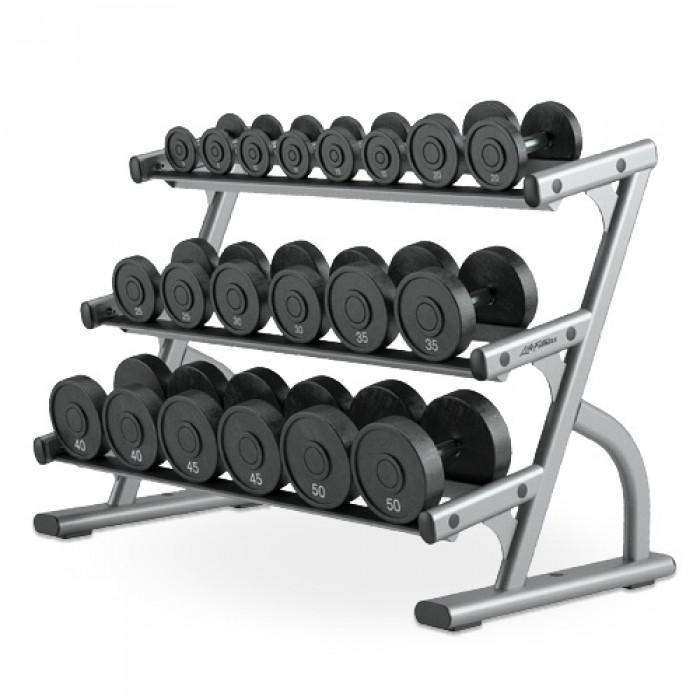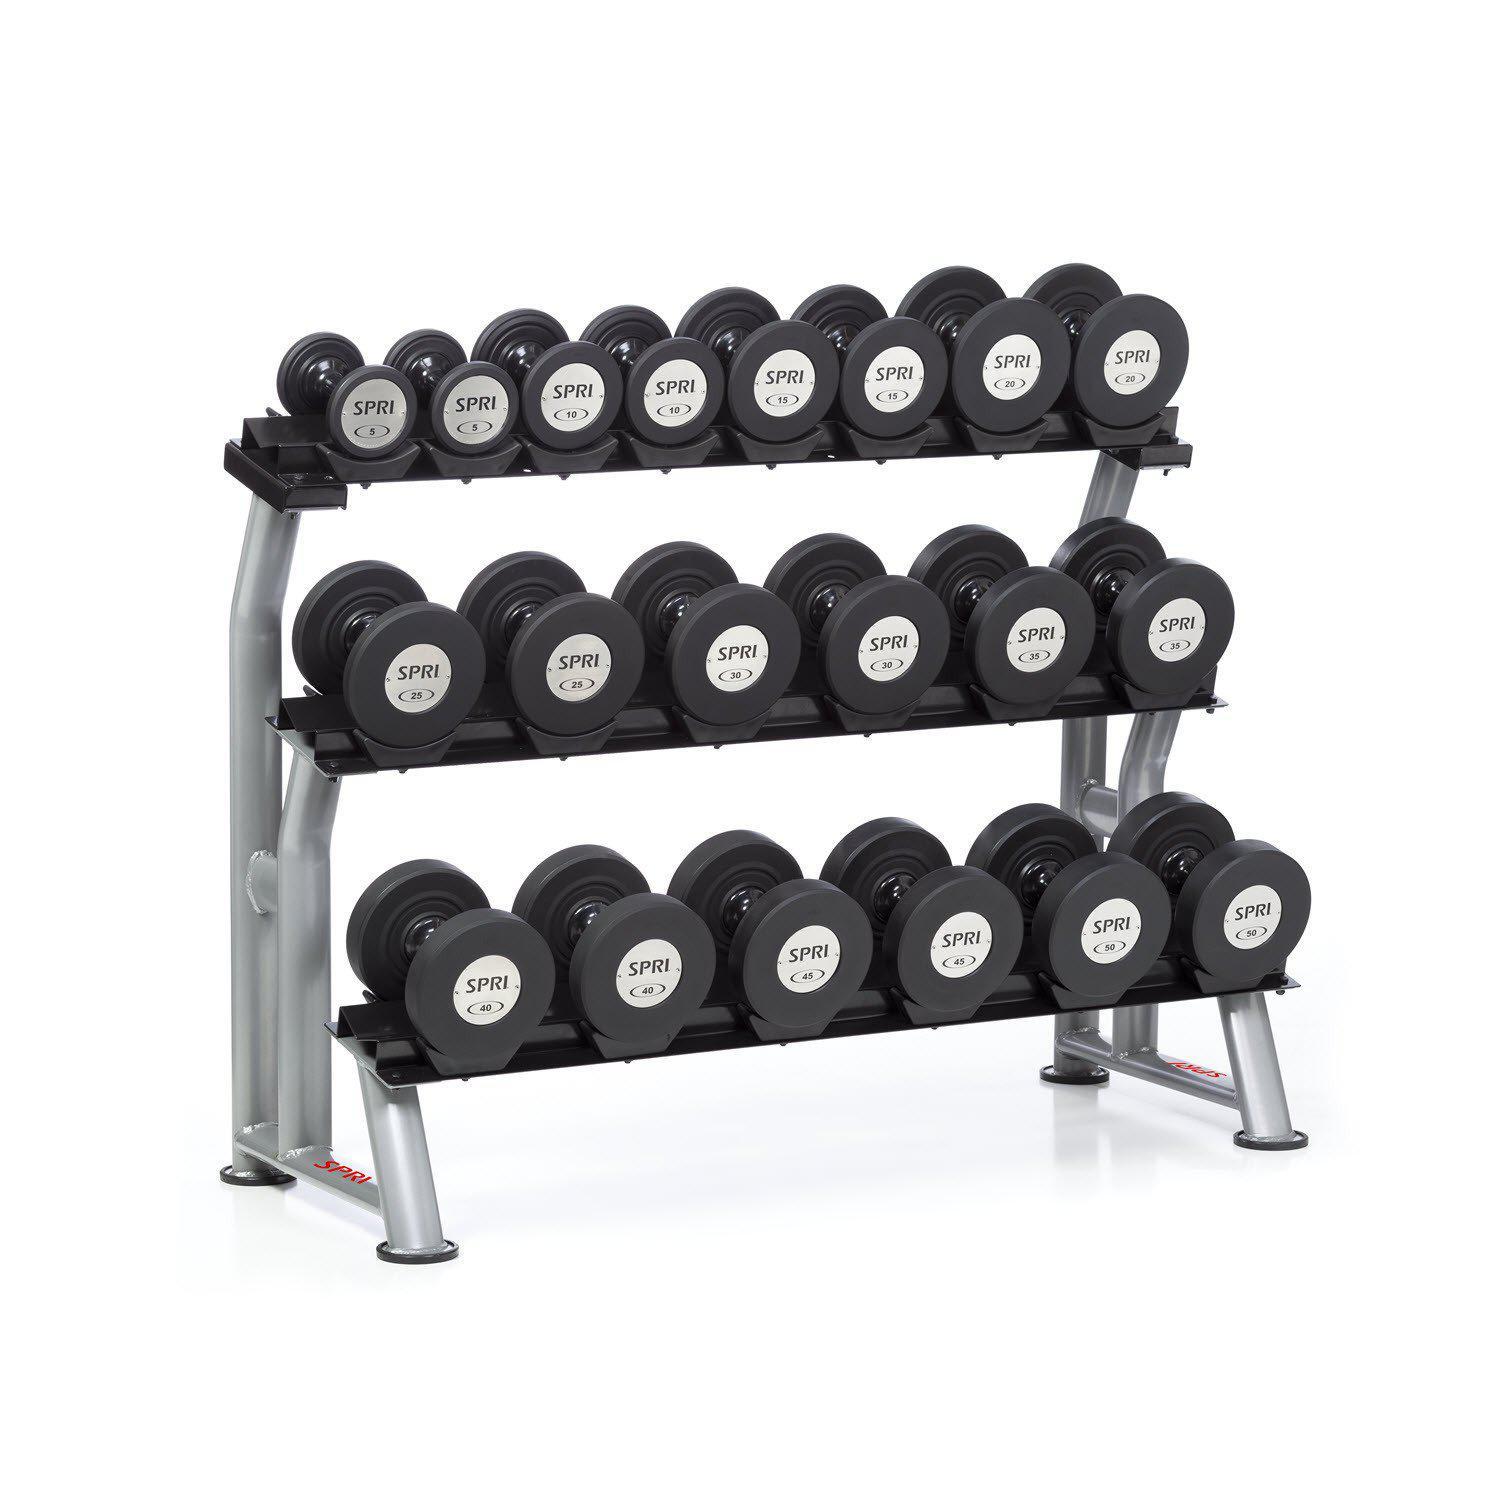The first image is the image on the left, the second image is the image on the right. For the images shown, is this caption "The weights on the rack in the image on the left are round." true? Answer yes or no. Yes. The first image is the image on the left, the second image is the image on the right. Evaluate the accuracy of this statement regarding the images: "One image shows a weight rack that holds three rows of dumbbells with hexagon-shaped ends.". Is it true? Answer yes or no. No. 